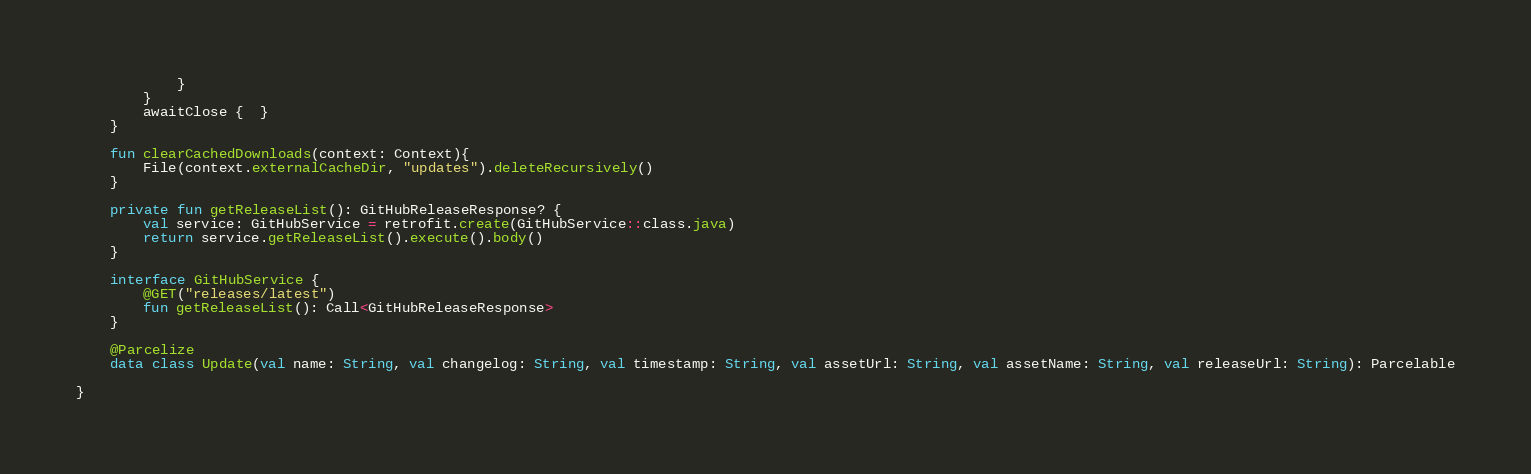Convert code to text. <code><loc_0><loc_0><loc_500><loc_500><_Kotlin_>            }
        }
        awaitClose {  }
    }

    fun clearCachedDownloads(context: Context){
        File(context.externalCacheDir, "updates").deleteRecursively()
    }

    private fun getReleaseList(): GitHubReleaseResponse? {
        val service: GitHubService = retrofit.create(GitHubService::class.java)
        return service.getReleaseList().execute().body()
    }

    interface GitHubService {
        @GET("releases/latest")
        fun getReleaseList(): Call<GitHubReleaseResponse>
    }

    @Parcelize
    data class Update(val name: String, val changelog: String, val timestamp: String, val assetUrl: String, val assetName: String, val releaseUrl: String): Parcelable

}</code> 